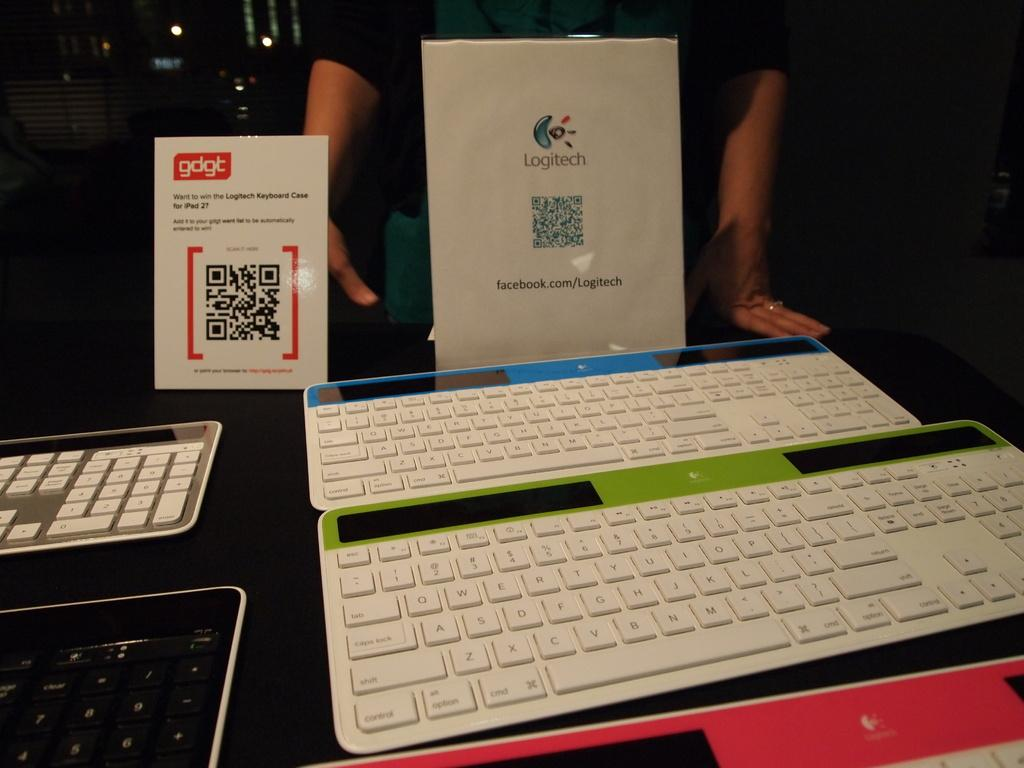Provide a one-sentence caption for the provided image. A display of keyboards in front of a Logitech sign. 